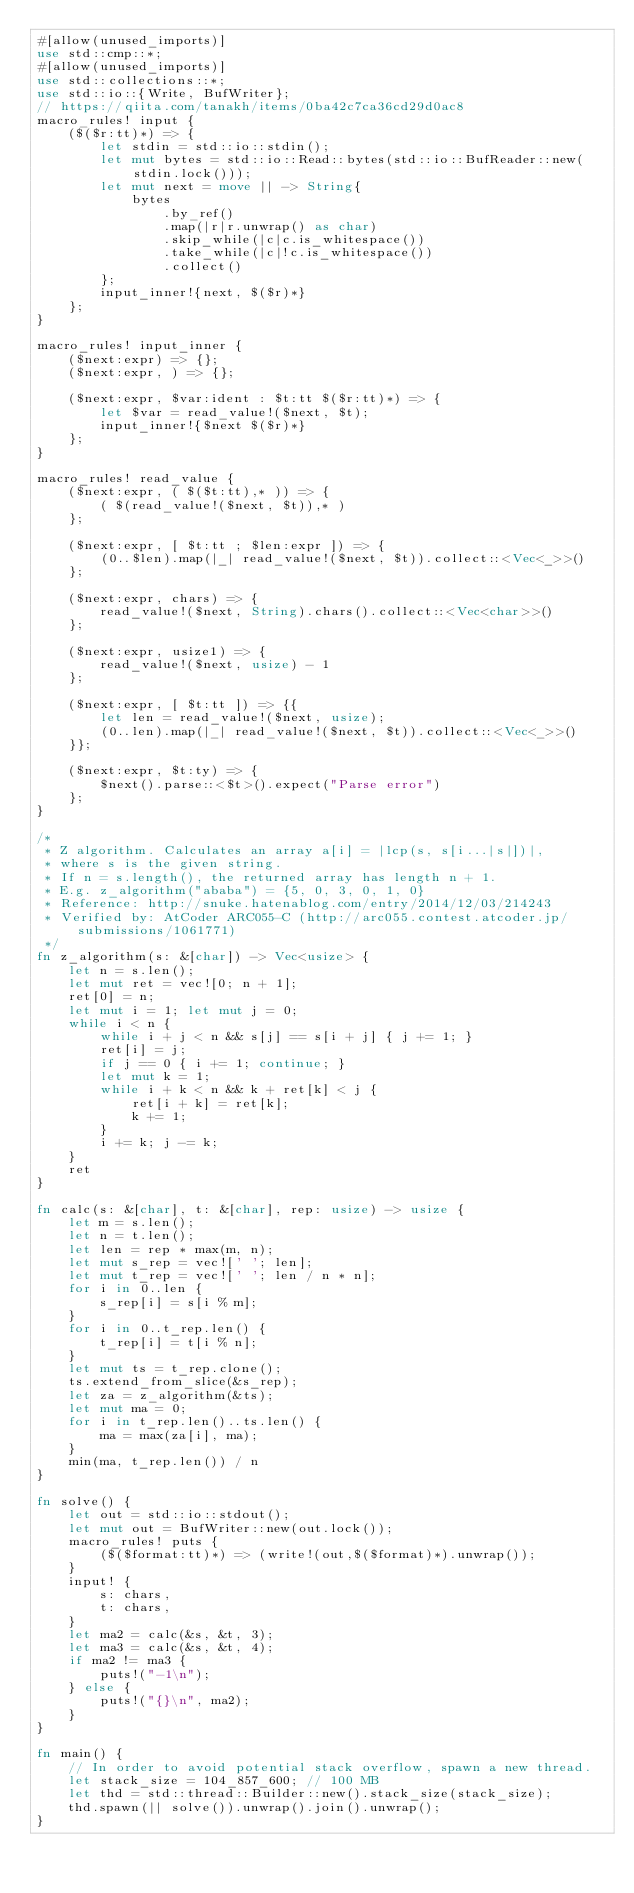<code> <loc_0><loc_0><loc_500><loc_500><_Rust_>#[allow(unused_imports)]
use std::cmp::*;
#[allow(unused_imports)]
use std::collections::*;
use std::io::{Write, BufWriter};
// https://qiita.com/tanakh/items/0ba42c7ca36cd29d0ac8
macro_rules! input {
    ($($r:tt)*) => {
        let stdin = std::io::stdin();
        let mut bytes = std::io::Read::bytes(std::io::BufReader::new(stdin.lock()));
        let mut next = move || -> String{
            bytes
                .by_ref()
                .map(|r|r.unwrap() as char)
                .skip_while(|c|c.is_whitespace())
                .take_while(|c|!c.is_whitespace())
                .collect()
        };
        input_inner!{next, $($r)*}
    };
}

macro_rules! input_inner {
    ($next:expr) => {};
    ($next:expr, ) => {};

    ($next:expr, $var:ident : $t:tt $($r:tt)*) => {
        let $var = read_value!($next, $t);
        input_inner!{$next $($r)*}
    };
}

macro_rules! read_value {
    ($next:expr, ( $($t:tt),* )) => {
        ( $(read_value!($next, $t)),* )
    };

    ($next:expr, [ $t:tt ; $len:expr ]) => {
        (0..$len).map(|_| read_value!($next, $t)).collect::<Vec<_>>()
    };

    ($next:expr, chars) => {
        read_value!($next, String).chars().collect::<Vec<char>>()
    };

    ($next:expr, usize1) => {
        read_value!($next, usize) - 1
    };

    ($next:expr, [ $t:tt ]) => {{
        let len = read_value!($next, usize);
        (0..len).map(|_| read_value!($next, $t)).collect::<Vec<_>>()
    }};

    ($next:expr, $t:ty) => {
        $next().parse::<$t>().expect("Parse error")
    };
}

/*
 * Z algorithm. Calculates an array a[i] = |lcp(s, s[i...|s|])|,
 * where s is the given string.
 * If n = s.length(), the returned array has length n + 1.
 * E.g. z_algorithm("ababa") = {5, 0, 3, 0, 1, 0}
 * Reference: http://snuke.hatenablog.com/entry/2014/12/03/214243
 * Verified by: AtCoder ARC055-C (http://arc055.contest.atcoder.jp/submissions/1061771)
 */
fn z_algorithm(s: &[char]) -> Vec<usize> {
    let n = s.len();
    let mut ret = vec![0; n + 1];
    ret[0] = n;
    let mut i = 1; let mut j = 0;
    while i < n {
        while i + j < n && s[j] == s[i + j] { j += 1; }
        ret[i] = j;
        if j == 0 { i += 1; continue; }
        let mut k = 1;
        while i + k < n && k + ret[k] < j {
            ret[i + k] = ret[k];
            k += 1;
        }
        i += k; j -= k;
    }
    ret
}

fn calc(s: &[char], t: &[char], rep: usize) -> usize {
    let m = s.len();
    let n = t.len();
    let len = rep * max(m, n);
    let mut s_rep = vec![' '; len];
    let mut t_rep = vec![' '; len / n * n];
    for i in 0..len {
        s_rep[i] = s[i % m];
    }
    for i in 0..t_rep.len() {
        t_rep[i] = t[i % n];
    }
    let mut ts = t_rep.clone();
    ts.extend_from_slice(&s_rep);
    let za = z_algorithm(&ts);
    let mut ma = 0;
    for i in t_rep.len()..ts.len() {
        ma = max(za[i], ma);
    }
    min(ma, t_rep.len()) / n
}

fn solve() {
    let out = std::io::stdout();
    let mut out = BufWriter::new(out.lock());
    macro_rules! puts {
        ($($format:tt)*) => (write!(out,$($format)*).unwrap());
    }
    input! {
        s: chars,
        t: chars,
    }
    let ma2 = calc(&s, &t, 3);
    let ma3 = calc(&s, &t, 4);
    if ma2 != ma3 {
        puts!("-1\n");
    } else {
        puts!("{}\n", ma2);
    }
}

fn main() {
    // In order to avoid potential stack overflow, spawn a new thread.
    let stack_size = 104_857_600; // 100 MB
    let thd = std::thread::Builder::new().stack_size(stack_size);
    thd.spawn(|| solve()).unwrap().join().unwrap();
}
</code> 